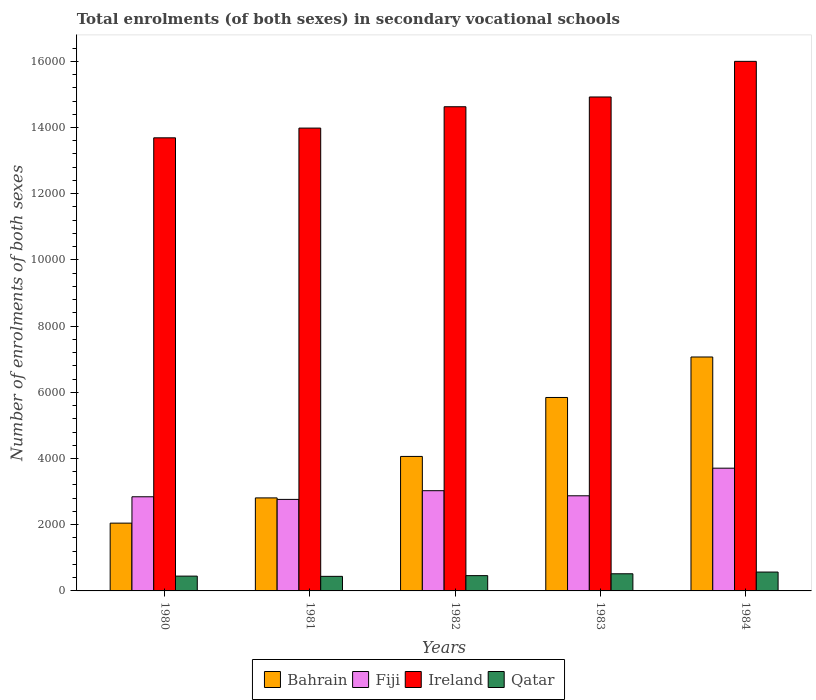Are the number of bars per tick equal to the number of legend labels?
Keep it short and to the point. Yes. Are the number of bars on each tick of the X-axis equal?
Offer a terse response. Yes. How many bars are there on the 5th tick from the left?
Offer a very short reply. 4. How many bars are there on the 1st tick from the right?
Your answer should be very brief. 4. In how many cases, is the number of bars for a given year not equal to the number of legend labels?
Keep it short and to the point. 0. What is the number of enrolments in secondary schools in Qatar in 1984?
Provide a short and direct response. 570. Across all years, what is the maximum number of enrolments in secondary schools in Bahrain?
Offer a terse response. 7067. Across all years, what is the minimum number of enrolments in secondary schools in Ireland?
Provide a short and direct response. 1.37e+04. In which year was the number of enrolments in secondary schools in Fiji maximum?
Provide a succinct answer. 1984. In which year was the number of enrolments in secondary schools in Fiji minimum?
Offer a very short reply. 1981. What is the total number of enrolments in secondary schools in Qatar in the graph?
Offer a terse response. 2437. What is the difference between the number of enrolments in secondary schools in Ireland in 1980 and that in 1983?
Provide a succinct answer. -1234. What is the difference between the number of enrolments in secondary schools in Fiji in 1981 and the number of enrolments in secondary schools in Bahrain in 1982?
Offer a very short reply. -1298. What is the average number of enrolments in secondary schools in Qatar per year?
Your answer should be compact. 487.4. In the year 1981, what is the difference between the number of enrolments in secondary schools in Ireland and number of enrolments in secondary schools in Bahrain?
Make the answer very short. 1.12e+04. What is the ratio of the number of enrolments in secondary schools in Bahrain in 1980 to that in 1984?
Your response must be concise. 0.29. Is the number of enrolments in secondary schools in Qatar in 1981 less than that in 1984?
Provide a short and direct response. Yes. What is the difference between the highest and the second highest number of enrolments in secondary schools in Qatar?
Provide a short and direct response. 52. What is the difference between the highest and the lowest number of enrolments in secondary schools in Fiji?
Offer a terse response. 943. In how many years, is the number of enrolments in secondary schools in Fiji greater than the average number of enrolments in secondary schools in Fiji taken over all years?
Offer a very short reply. 1. Is it the case that in every year, the sum of the number of enrolments in secondary schools in Bahrain and number of enrolments in secondary schools in Qatar is greater than the sum of number of enrolments in secondary schools in Ireland and number of enrolments in secondary schools in Fiji?
Your answer should be very brief. No. What does the 1st bar from the left in 1982 represents?
Provide a succinct answer. Bahrain. What does the 1st bar from the right in 1980 represents?
Your response must be concise. Qatar. Is it the case that in every year, the sum of the number of enrolments in secondary schools in Ireland and number of enrolments in secondary schools in Qatar is greater than the number of enrolments in secondary schools in Fiji?
Your answer should be very brief. Yes. How many bars are there?
Offer a very short reply. 20. Are all the bars in the graph horizontal?
Provide a short and direct response. No. What is the difference between two consecutive major ticks on the Y-axis?
Ensure brevity in your answer.  2000. Are the values on the major ticks of Y-axis written in scientific E-notation?
Provide a succinct answer. No. Does the graph contain any zero values?
Give a very brief answer. No. Where does the legend appear in the graph?
Keep it short and to the point. Bottom center. How many legend labels are there?
Provide a short and direct response. 4. What is the title of the graph?
Provide a short and direct response. Total enrolments (of both sexes) in secondary vocational schools. Does "San Marino" appear as one of the legend labels in the graph?
Your response must be concise. No. What is the label or title of the Y-axis?
Your response must be concise. Number of enrolments of both sexes. What is the Number of enrolments of both sexes of Bahrain in 1980?
Your answer should be very brief. 2048. What is the Number of enrolments of both sexes in Fiji in 1980?
Offer a terse response. 2844. What is the Number of enrolments of both sexes in Ireland in 1980?
Offer a terse response. 1.37e+04. What is the Number of enrolments of both sexes in Qatar in 1980?
Your answer should be very brief. 447. What is the Number of enrolments of both sexes in Bahrain in 1981?
Provide a short and direct response. 2810. What is the Number of enrolments of both sexes in Fiji in 1981?
Your answer should be very brief. 2765. What is the Number of enrolments of both sexes of Ireland in 1981?
Your answer should be very brief. 1.40e+04. What is the Number of enrolments of both sexes in Qatar in 1981?
Keep it short and to the point. 440. What is the Number of enrolments of both sexes in Bahrain in 1982?
Your answer should be very brief. 4063. What is the Number of enrolments of both sexes in Fiji in 1982?
Give a very brief answer. 3028. What is the Number of enrolments of both sexes of Ireland in 1982?
Your response must be concise. 1.46e+04. What is the Number of enrolments of both sexes in Qatar in 1982?
Your answer should be compact. 462. What is the Number of enrolments of both sexes of Bahrain in 1983?
Provide a succinct answer. 5844. What is the Number of enrolments of both sexes in Fiji in 1983?
Your answer should be compact. 2874. What is the Number of enrolments of both sexes of Ireland in 1983?
Make the answer very short. 1.49e+04. What is the Number of enrolments of both sexes in Qatar in 1983?
Give a very brief answer. 518. What is the Number of enrolments of both sexes in Bahrain in 1984?
Give a very brief answer. 7067. What is the Number of enrolments of both sexes of Fiji in 1984?
Ensure brevity in your answer.  3708. What is the Number of enrolments of both sexes in Ireland in 1984?
Give a very brief answer. 1.60e+04. What is the Number of enrolments of both sexes in Qatar in 1984?
Provide a succinct answer. 570. Across all years, what is the maximum Number of enrolments of both sexes in Bahrain?
Provide a succinct answer. 7067. Across all years, what is the maximum Number of enrolments of both sexes of Fiji?
Offer a terse response. 3708. Across all years, what is the maximum Number of enrolments of both sexes of Ireland?
Provide a succinct answer. 1.60e+04. Across all years, what is the maximum Number of enrolments of both sexes of Qatar?
Give a very brief answer. 570. Across all years, what is the minimum Number of enrolments of both sexes in Bahrain?
Provide a succinct answer. 2048. Across all years, what is the minimum Number of enrolments of both sexes in Fiji?
Offer a terse response. 2765. Across all years, what is the minimum Number of enrolments of both sexes in Ireland?
Your response must be concise. 1.37e+04. Across all years, what is the minimum Number of enrolments of both sexes of Qatar?
Offer a very short reply. 440. What is the total Number of enrolments of both sexes in Bahrain in the graph?
Give a very brief answer. 2.18e+04. What is the total Number of enrolments of both sexes in Fiji in the graph?
Your response must be concise. 1.52e+04. What is the total Number of enrolments of both sexes of Ireland in the graph?
Offer a very short reply. 7.32e+04. What is the total Number of enrolments of both sexes in Qatar in the graph?
Make the answer very short. 2437. What is the difference between the Number of enrolments of both sexes in Bahrain in 1980 and that in 1981?
Ensure brevity in your answer.  -762. What is the difference between the Number of enrolments of both sexes of Fiji in 1980 and that in 1981?
Offer a very short reply. 79. What is the difference between the Number of enrolments of both sexes in Ireland in 1980 and that in 1981?
Your answer should be compact. -294. What is the difference between the Number of enrolments of both sexes of Bahrain in 1980 and that in 1982?
Provide a short and direct response. -2015. What is the difference between the Number of enrolments of both sexes in Fiji in 1980 and that in 1982?
Offer a terse response. -184. What is the difference between the Number of enrolments of both sexes in Ireland in 1980 and that in 1982?
Provide a short and direct response. -939. What is the difference between the Number of enrolments of both sexes of Qatar in 1980 and that in 1982?
Offer a terse response. -15. What is the difference between the Number of enrolments of both sexes in Bahrain in 1980 and that in 1983?
Ensure brevity in your answer.  -3796. What is the difference between the Number of enrolments of both sexes in Ireland in 1980 and that in 1983?
Provide a succinct answer. -1234. What is the difference between the Number of enrolments of both sexes of Qatar in 1980 and that in 1983?
Your answer should be very brief. -71. What is the difference between the Number of enrolments of both sexes in Bahrain in 1980 and that in 1984?
Give a very brief answer. -5019. What is the difference between the Number of enrolments of both sexes in Fiji in 1980 and that in 1984?
Provide a succinct answer. -864. What is the difference between the Number of enrolments of both sexes in Ireland in 1980 and that in 1984?
Give a very brief answer. -2310. What is the difference between the Number of enrolments of both sexes in Qatar in 1980 and that in 1984?
Provide a short and direct response. -123. What is the difference between the Number of enrolments of both sexes in Bahrain in 1981 and that in 1982?
Offer a terse response. -1253. What is the difference between the Number of enrolments of both sexes of Fiji in 1981 and that in 1982?
Provide a succinct answer. -263. What is the difference between the Number of enrolments of both sexes of Ireland in 1981 and that in 1982?
Offer a very short reply. -645. What is the difference between the Number of enrolments of both sexes in Qatar in 1981 and that in 1982?
Give a very brief answer. -22. What is the difference between the Number of enrolments of both sexes of Bahrain in 1981 and that in 1983?
Keep it short and to the point. -3034. What is the difference between the Number of enrolments of both sexes of Fiji in 1981 and that in 1983?
Ensure brevity in your answer.  -109. What is the difference between the Number of enrolments of both sexes in Ireland in 1981 and that in 1983?
Offer a terse response. -940. What is the difference between the Number of enrolments of both sexes of Qatar in 1981 and that in 1983?
Make the answer very short. -78. What is the difference between the Number of enrolments of both sexes in Bahrain in 1981 and that in 1984?
Provide a short and direct response. -4257. What is the difference between the Number of enrolments of both sexes of Fiji in 1981 and that in 1984?
Your answer should be compact. -943. What is the difference between the Number of enrolments of both sexes in Ireland in 1981 and that in 1984?
Provide a succinct answer. -2016. What is the difference between the Number of enrolments of both sexes in Qatar in 1981 and that in 1984?
Offer a very short reply. -130. What is the difference between the Number of enrolments of both sexes of Bahrain in 1982 and that in 1983?
Your response must be concise. -1781. What is the difference between the Number of enrolments of both sexes in Fiji in 1982 and that in 1983?
Your response must be concise. 154. What is the difference between the Number of enrolments of both sexes in Ireland in 1982 and that in 1983?
Your response must be concise. -295. What is the difference between the Number of enrolments of both sexes of Qatar in 1982 and that in 1983?
Your answer should be very brief. -56. What is the difference between the Number of enrolments of both sexes of Bahrain in 1982 and that in 1984?
Offer a very short reply. -3004. What is the difference between the Number of enrolments of both sexes of Fiji in 1982 and that in 1984?
Ensure brevity in your answer.  -680. What is the difference between the Number of enrolments of both sexes in Ireland in 1982 and that in 1984?
Ensure brevity in your answer.  -1371. What is the difference between the Number of enrolments of both sexes of Qatar in 1982 and that in 1984?
Make the answer very short. -108. What is the difference between the Number of enrolments of both sexes in Bahrain in 1983 and that in 1984?
Give a very brief answer. -1223. What is the difference between the Number of enrolments of both sexes of Fiji in 1983 and that in 1984?
Give a very brief answer. -834. What is the difference between the Number of enrolments of both sexes of Ireland in 1983 and that in 1984?
Your response must be concise. -1076. What is the difference between the Number of enrolments of both sexes in Qatar in 1983 and that in 1984?
Keep it short and to the point. -52. What is the difference between the Number of enrolments of both sexes of Bahrain in 1980 and the Number of enrolments of both sexes of Fiji in 1981?
Offer a terse response. -717. What is the difference between the Number of enrolments of both sexes in Bahrain in 1980 and the Number of enrolments of both sexes in Ireland in 1981?
Make the answer very short. -1.19e+04. What is the difference between the Number of enrolments of both sexes of Bahrain in 1980 and the Number of enrolments of both sexes of Qatar in 1981?
Give a very brief answer. 1608. What is the difference between the Number of enrolments of both sexes of Fiji in 1980 and the Number of enrolments of both sexes of Ireland in 1981?
Provide a succinct answer. -1.11e+04. What is the difference between the Number of enrolments of both sexes in Fiji in 1980 and the Number of enrolments of both sexes in Qatar in 1981?
Offer a terse response. 2404. What is the difference between the Number of enrolments of both sexes of Ireland in 1980 and the Number of enrolments of both sexes of Qatar in 1981?
Keep it short and to the point. 1.32e+04. What is the difference between the Number of enrolments of both sexes in Bahrain in 1980 and the Number of enrolments of both sexes in Fiji in 1982?
Make the answer very short. -980. What is the difference between the Number of enrolments of both sexes of Bahrain in 1980 and the Number of enrolments of both sexes of Ireland in 1982?
Offer a very short reply. -1.26e+04. What is the difference between the Number of enrolments of both sexes of Bahrain in 1980 and the Number of enrolments of both sexes of Qatar in 1982?
Offer a very short reply. 1586. What is the difference between the Number of enrolments of both sexes in Fiji in 1980 and the Number of enrolments of both sexes in Ireland in 1982?
Offer a terse response. -1.18e+04. What is the difference between the Number of enrolments of both sexes in Fiji in 1980 and the Number of enrolments of both sexes in Qatar in 1982?
Provide a succinct answer. 2382. What is the difference between the Number of enrolments of both sexes of Ireland in 1980 and the Number of enrolments of both sexes of Qatar in 1982?
Give a very brief answer. 1.32e+04. What is the difference between the Number of enrolments of both sexes of Bahrain in 1980 and the Number of enrolments of both sexes of Fiji in 1983?
Keep it short and to the point. -826. What is the difference between the Number of enrolments of both sexes of Bahrain in 1980 and the Number of enrolments of both sexes of Ireland in 1983?
Offer a terse response. -1.29e+04. What is the difference between the Number of enrolments of both sexes of Bahrain in 1980 and the Number of enrolments of both sexes of Qatar in 1983?
Your response must be concise. 1530. What is the difference between the Number of enrolments of both sexes in Fiji in 1980 and the Number of enrolments of both sexes in Ireland in 1983?
Ensure brevity in your answer.  -1.21e+04. What is the difference between the Number of enrolments of both sexes in Fiji in 1980 and the Number of enrolments of both sexes in Qatar in 1983?
Your response must be concise. 2326. What is the difference between the Number of enrolments of both sexes of Ireland in 1980 and the Number of enrolments of both sexes of Qatar in 1983?
Provide a succinct answer. 1.32e+04. What is the difference between the Number of enrolments of both sexes in Bahrain in 1980 and the Number of enrolments of both sexes in Fiji in 1984?
Offer a very short reply. -1660. What is the difference between the Number of enrolments of both sexes in Bahrain in 1980 and the Number of enrolments of both sexes in Ireland in 1984?
Make the answer very short. -1.40e+04. What is the difference between the Number of enrolments of both sexes in Bahrain in 1980 and the Number of enrolments of both sexes in Qatar in 1984?
Give a very brief answer. 1478. What is the difference between the Number of enrolments of both sexes in Fiji in 1980 and the Number of enrolments of both sexes in Ireland in 1984?
Provide a succinct answer. -1.32e+04. What is the difference between the Number of enrolments of both sexes of Fiji in 1980 and the Number of enrolments of both sexes of Qatar in 1984?
Make the answer very short. 2274. What is the difference between the Number of enrolments of both sexes of Ireland in 1980 and the Number of enrolments of both sexes of Qatar in 1984?
Your answer should be compact. 1.31e+04. What is the difference between the Number of enrolments of both sexes in Bahrain in 1981 and the Number of enrolments of both sexes in Fiji in 1982?
Keep it short and to the point. -218. What is the difference between the Number of enrolments of both sexes of Bahrain in 1981 and the Number of enrolments of both sexes of Ireland in 1982?
Offer a very short reply. -1.18e+04. What is the difference between the Number of enrolments of both sexes in Bahrain in 1981 and the Number of enrolments of both sexes in Qatar in 1982?
Your answer should be compact. 2348. What is the difference between the Number of enrolments of both sexes in Fiji in 1981 and the Number of enrolments of both sexes in Ireland in 1982?
Provide a short and direct response. -1.19e+04. What is the difference between the Number of enrolments of both sexes of Fiji in 1981 and the Number of enrolments of both sexes of Qatar in 1982?
Make the answer very short. 2303. What is the difference between the Number of enrolments of both sexes in Ireland in 1981 and the Number of enrolments of both sexes in Qatar in 1982?
Provide a succinct answer. 1.35e+04. What is the difference between the Number of enrolments of both sexes of Bahrain in 1981 and the Number of enrolments of both sexes of Fiji in 1983?
Give a very brief answer. -64. What is the difference between the Number of enrolments of both sexes in Bahrain in 1981 and the Number of enrolments of both sexes in Ireland in 1983?
Provide a succinct answer. -1.21e+04. What is the difference between the Number of enrolments of both sexes of Bahrain in 1981 and the Number of enrolments of both sexes of Qatar in 1983?
Your answer should be very brief. 2292. What is the difference between the Number of enrolments of both sexes of Fiji in 1981 and the Number of enrolments of both sexes of Ireland in 1983?
Offer a terse response. -1.22e+04. What is the difference between the Number of enrolments of both sexes in Fiji in 1981 and the Number of enrolments of both sexes in Qatar in 1983?
Provide a short and direct response. 2247. What is the difference between the Number of enrolments of both sexes of Ireland in 1981 and the Number of enrolments of both sexes of Qatar in 1983?
Provide a short and direct response. 1.35e+04. What is the difference between the Number of enrolments of both sexes in Bahrain in 1981 and the Number of enrolments of both sexes in Fiji in 1984?
Your answer should be very brief. -898. What is the difference between the Number of enrolments of both sexes of Bahrain in 1981 and the Number of enrolments of both sexes of Ireland in 1984?
Offer a very short reply. -1.32e+04. What is the difference between the Number of enrolments of both sexes in Bahrain in 1981 and the Number of enrolments of both sexes in Qatar in 1984?
Ensure brevity in your answer.  2240. What is the difference between the Number of enrolments of both sexes of Fiji in 1981 and the Number of enrolments of both sexes of Ireland in 1984?
Keep it short and to the point. -1.32e+04. What is the difference between the Number of enrolments of both sexes of Fiji in 1981 and the Number of enrolments of both sexes of Qatar in 1984?
Give a very brief answer. 2195. What is the difference between the Number of enrolments of both sexes of Ireland in 1981 and the Number of enrolments of both sexes of Qatar in 1984?
Your answer should be compact. 1.34e+04. What is the difference between the Number of enrolments of both sexes in Bahrain in 1982 and the Number of enrolments of both sexes in Fiji in 1983?
Give a very brief answer. 1189. What is the difference between the Number of enrolments of both sexes of Bahrain in 1982 and the Number of enrolments of both sexes of Ireland in 1983?
Keep it short and to the point. -1.09e+04. What is the difference between the Number of enrolments of both sexes in Bahrain in 1982 and the Number of enrolments of both sexes in Qatar in 1983?
Ensure brevity in your answer.  3545. What is the difference between the Number of enrolments of both sexes of Fiji in 1982 and the Number of enrolments of both sexes of Ireland in 1983?
Your answer should be compact. -1.19e+04. What is the difference between the Number of enrolments of both sexes in Fiji in 1982 and the Number of enrolments of both sexes in Qatar in 1983?
Make the answer very short. 2510. What is the difference between the Number of enrolments of both sexes in Ireland in 1982 and the Number of enrolments of both sexes in Qatar in 1983?
Your answer should be very brief. 1.41e+04. What is the difference between the Number of enrolments of both sexes of Bahrain in 1982 and the Number of enrolments of both sexes of Fiji in 1984?
Offer a very short reply. 355. What is the difference between the Number of enrolments of both sexes in Bahrain in 1982 and the Number of enrolments of both sexes in Ireland in 1984?
Your answer should be very brief. -1.19e+04. What is the difference between the Number of enrolments of both sexes in Bahrain in 1982 and the Number of enrolments of both sexes in Qatar in 1984?
Provide a short and direct response. 3493. What is the difference between the Number of enrolments of both sexes in Fiji in 1982 and the Number of enrolments of both sexes in Ireland in 1984?
Give a very brief answer. -1.30e+04. What is the difference between the Number of enrolments of both sexes in Fiji in 1982 and the Number of enrolments of both sexes in Qatar in 1984?
Your response must be concise. 2458. What is the difference between the Number of enrolments of both sexes of Ireland in 1982 and the Number of enrolments of both sexes of Qatar in 1984?
Your answer should be very brief. 1.41e+04. What is the difference between the Number of enrolments of both sexes of Bahrain in 1983 and the Number of enrolments of both sexes of Fiji in 1984?
Give a very brief answer. 2136. What is the difference between the Number of enrolments of both sexes of Bahrain in 1983 and the Number of enrolments of both sexes of Ireland in 1984?
Give a very brief answer. -1.02e+04. What is the difference between the Number of enrolments of both sexes in Bahrain in 1983 and the Number of enrolments of both sexes in Qatar in 1984?
Ensure brevity in your answer.  5274. What is the difference between the Number of enrolments of both sexes in Fiji in 1983 and the Number of enrolments of both sexes in Ireland in 1984?
Make the answer very short. -1.31e+04. What is the difference between the Number of enrolments of both sexes of Fiji in 1983 and the Number of enrolments of both sexes of Qatar in 1984?
Your answer should be compact. 2304. What is the difference between the Number of enrolments of both sexes of Ireland in 1983 and the Number of enrolments of both sexes of Qatar in 1984?
Your answer should be compact. 1.44e+04. What is the average Number of enrolments of both sexes of Bahrain per year?
Your answer should be compact. 4366.4. What is the average Number of enrolments of both sexes of Fiji per year?
Offer a very short reply. 3043.8. What is the average Number of enrolments of both sexes of Ireland per year?
Keep it short and to the point. 1.46e+04. What is the average Number of enrolments of both sexes in Qatar per year?
Offer a very short reply. 487.4. In the year 1980, what is the difference between the Number of enrolments of both sexes of Bahrain and Number of enrolments of both sexes of Fiji?
Provide a short and direct response. -796. In the year 1980, what is the difference between the Number of enrolments of both sexes of Bahrain and Number of enrolments of both sexes of Ireland?
Keep it short and to the point. -1.16e+04. In the year 1980, what is the difference between the Number of enrolments of both sexes of Bahrain and Number of enrolments of both sexes of Qatar?
Keep it short and to the point. 1601. In the year 1980, what is the difference between the Number of enrolments of both sexes in Fiji and Number of enrolments of both sexes in Ireland?
Provide a short and direct response. -1.08e+04. In the year 1980, what is the difference between the Number of enrolments of both sexes of Fiji and Number of enrolments of both sexes of Qatar?
Offer a very short reply. 2397. In the year 1980, what is the difference between the Number of enrolments of both sexes in Ireland and Number of enrolments of both sexes in Qatar?
Your response must be concise. 1.32e+04. In the year 1981, what is the difference between the Number of enrolments of both sexes in Bahrain and Number of enrolments of both sexes in Ireland?
Make the answer very short. -1.12e+04. In the year 1981, what is the difference between the Number of enrolments of both sexes in Bahrain and Number of enrolments of both sexes in Qatar?
Make the answer very short. 2370. In the year 1981, what is the difference between the Number of enrolments of both sexes in Fiji and Number of enrolments of both sexes in Ireland?
Keep it short and to the point. -1.12e+04. In the year 1981, what is the difference between the Number of enrolments of both sexes in Fiji and Number of enrolments of both sexes in Qatar?
Your answer should be compact. 2325. In the year 1981, what is the difference between the Number of enrolments of both sexes of Ireland and Number of enrolments of both sexes of Qatar?
Your response must be concise. 1.35e+04. In the year 1982, what is the difference between the Number of enrolments of both sexes in Bahrain and Number of enrolments of both sexes in Fiji?
Offer a very short reply. 1035. In the year 1982, what is the difference between the Number of enrolments of both sexes in Bahrain and Number of enrolments of both sexes in Ireland?
Offer a very short reply. -1.06e+04. In the year 1982, what is the difference between the Number of enrolments of both sexes of Bahrain and Number of enrolments of both sexes of Qatar?
Provide a succinct answer. 3601. In the year 1982, what is the difference between the Number of enrolments of both sexes in Fiji and Number of enrolments of both sexes in Ireland?
Your response must be concise. -1.16e+04. In the year 1982, what is the difference between the Number of enrolments of both sexes of Fiji and Number of enrolments of both sexes of Qatar?
Ensure brevity in your answer.  2566. In the year 1982, what is the difference between the Number of enrolments of both sexes of Ireland and Number of enrolments of both sexes of Qatar?
Offer a terse response. 1.42e+04. In the year 1983, what is the difference between the Number of enrolments of both sexes in Bahrain and Number of enrolments of both sexes in Fiji?
Ensure brevity in your answer.  2970. In the year 1983, what is the difference between the Number of enrolments of both sexes in Bahrain and Number of enrolments of both sexes in Ireland?
Offer a terse response. -9078. In the year 1983, what is the difference between the Number of enrolments of both sexes of Bahrain and Number of enrolments of both sexes of Qatar?
Offer a terse response. 5326. In the year 1983, what is the difference between the Number of enrolments of both sexes of Fiji and Number of enrolments of both sexes of Ireland?
Provide a succinct answer. -1.20e+04. In the year 1983, what is the difference between the Number of enrolments of both sexes of Fiji and Number of enrolments of both sexes of Qatar?
Provide a short and direct response. 2356. In the year 1983, what is the difference between the Number of enrolments of both sexes of Ireland and Number of enrolments of both sexes of Qatar?
Provide a succinct answer. 1.44e+04. In the year 1984, what is the difference between the Number of enrolments of both sexes in Bahrain and Number of enrolments of both sexes in Fiji?
Offer a very short reply. 3359. In the year 1984, what is the difference between the Number of enrolments of both sexes in Bahrain and Number of enrolments of both sexes in Ireland?
Provide a short and direct response. -8931. In the year 1984, what is the difference between the Number of enrolments of both sexes of Bahrain and Number of enrolments of both sexes of Qatar?
Make the answer very short. 6497. In the year 1984, what is the difference between the Number of enrolments of both sexes in Fiji and Number of enrolments of both sexes in Ireland?
Provide a succinct answer. -1.23e+04. In the year 1984, what is the difference between the Number of enrolments of both sexes in Fiji and Number of enrolments of both sexes in Qatar?
Give a very brief answer. 3138. In the year 1984, what is the difference between the Number of enrolments of both sexes of Ireland and Number of enrolments of both sexes of Qatar?
Your answer should be compact. 1.54e+04. What is the ratio of the Number of enrolments of both sexes of Bahrain in 1980 to that in 1981?
Ensure brevity in your answer.  0.73. What is the ratio of the Number of enrolments of both sexes in Fiji in 1980 to that in 1981?
Provide a succinct answer. 1.03. What is the ratio of the Number of enrolments of both sexes in Qatar in 1980 to that in 1981?
Your response must be concise. 1.02. What is the ratio of the Number of enrolments of both sexes of Bahrain in 1980 to that in 1982?
Your answer should be very brief. 0.5. What is the ratio of the Number of enrolments of both sexes in Fiji in 1980 to that in 1982?
Your answer should be compact. 0.94. What is the ratio of the Number of enrolments of both sexes in Ireland in 1980 to that in 1982?
Give a very brief answer. 0.94. What is the ratio of the Number of enrolments of both sexes of Qatar in 1980 to that in 1982?
Make the answer very short. 0.97. What is the ratio of the Number of enrolments of both sexes in Bahrain in 1980 to that in 1983?
Ensure brevity in your answer.  0.35. What is the ratio of the Number of enrolments of both sexes of Fiji in 1980 to that in 1983?
Give a very brief answer. 0.99. What is the ratio of the Number of enrolments of both sexes in Ireland in 1980 to that in 1983?
Keep it short and to the point. 0.92. What is the ratio of the Number of enrolments of both sexes of Qatar in 1980 to that in 1983?
Give a very brief answer. 0.86. What is the ratio of the Number of enrolments of both sexes of Bahrain in 1980 to that in 1984?
Ensure brevity in your answer.  0.29. What is the ratio of the Number of enrolments of both sexes in Fiji in 1980 to that in 1984?
Offer a very short reply. 0.77. What is the ratio of the Number of enrolments of both sexes in Ireland in 1980 to that in 1984?
Your answer should be compact. 0.86. What is the ratio of the Number of enrolments of both sexes in Qatar in 1980 to that in 1984?
Give a very brief answer. 0.78. What is the ratio of the Number of enrolments of both sexes of Bahrain in 1981 to that in 1982?
Ensure brevity in your answer.  0.69. What is the ratio of the Number of enrolments of both sexes of Fiji in 1981 to that in 1982?
Your response must be concise. 0.91. What is the ratio of the Number of enrolments of both sexes of Ireland in 1981 to that in 1982?
Keep it short and to the point. 0.96. What is the ratio of the Number of enrolments of both sexes of Qatar in 1981 to that in 1982?
Your response must be concise. 0.95. What is the ratio of the Number of enrolments of both sexes of Bahrain in 1981 to that in 1983?
Offer a terse response. 0.48. What is the ratio of the Number of enrolments of both sexes in Fiji in 1981 to that in 1983?
Offer a terse response. 0.96. What is the ratio of the Number of enrolments of both sexes of Ireland in 1981 to that in 1983?
Your answer should be very brief. 0.94. What is the ratio of the Number of enrolments of both sexes in Qatar in 1981 to that in 1983?
Provide a succinct answer. 0.85. What is the ratio of the Number of enrolments of both sexes of Bahrain in 1981 to that in 1984?
Provide a succinct answer. 0.4. What is the ratio of the Number of enrolments of both sexes in Fiji in 1981 to that in 1984?
Make the answer very short. 0.75. What is the ratio of the Number of enrolments of both sexes in Ireland in 1981 to that in 1984?
Make the answer very short. 0.87. What is the ratio of the Number of enrolments of both sexes of Qatar in 1981 to that in 1984?
Offer a very short reply. 0.77. What is the ratio of the Number of enrolments of both sexes of Bahrain in 1982 to that in 1983?
Offer a very short reply. 0.7. What is the ratio of the Number of enrolments of both sexes of Fiji in 1982 to that in 1983?
Provide a short and direct response. 1.05. What is the ratio of the Number of enrolments of both sexes of Ireland in 1982 to that in 1983?
Offer a terse response. 0.98. What is the ratio of the Number of enrolments of both sexes in Qatar in 1982 to that in 1983?
Your answer should be very brief. 0.89. What is the ratio of the Number of enrolments of both sexes of Bahrain in 1982 to that in 1984?
Provide a short and direct response. 0.57. What is the ratio of the Number of enrolments of both sexes of Fiji in 1982 to that in 1984?
Make the answer very short. 0.82. What is the ratio of the Number of enrolments of both sexes of Ireland in 1982 to that in 1984?
Make the answer very short. 0.91. What is the ratio of the Number of enrolments of both sexes of Qatar in 1982 to that in 1984?
Your answer should be compact. 0.81. What is the ratio of the Number of enrolments of both sexes of Bahrain in 1983 to that in 1984?
Offer a very short reply. 0.83. What is the ratio of the Number of enrolments of both sexes in Fiji in 1983 to that in 1984?
Your response must be concise. 0.78. What is the ratio of the Number of enrolments of both sexes in Ireland in 1983 to that in 1984?
Keep it short and to the point. 0.93. What is the ratio of the Number of enrolments of both sexes of Qatar in 1983 to that in 1984?
Give a very brief answer. 0.91. What is the difference between the highest and the second highest Number of enrolments of both sexes of Bahrain?
Provide a succinct answer. 1223. What is the difference between the highest and the second highest Number of enrolments of both sexes of Fiji?
Ensure brevity in your answer.  680. What is the difference between the highest and the second highest Number of enrolments of both sexes in Ireland?
Your response must be concise. 1076. What is the difference between the highest and the second highest Number of enrolments of both sexes of Qatar?
Keep it short and to the point. 52. What is the difference between the highest and the lowest Number of enrolments of both sexes of Bahrain?
Provide a short and direct response. 5019. What is the difference between the highest and the lowest Number of enrolments of both sexes of Fiji?
Provide a short and direct response. 943. What is the difference between the highest and the lowest Number of enrolments of both sexes in Ireland?
Ensure brevity in your answer.  2310. What is the difference between the highest and the lowest Number of enrolments of both sexes in Qatar?
Your response must be concise. 130. 